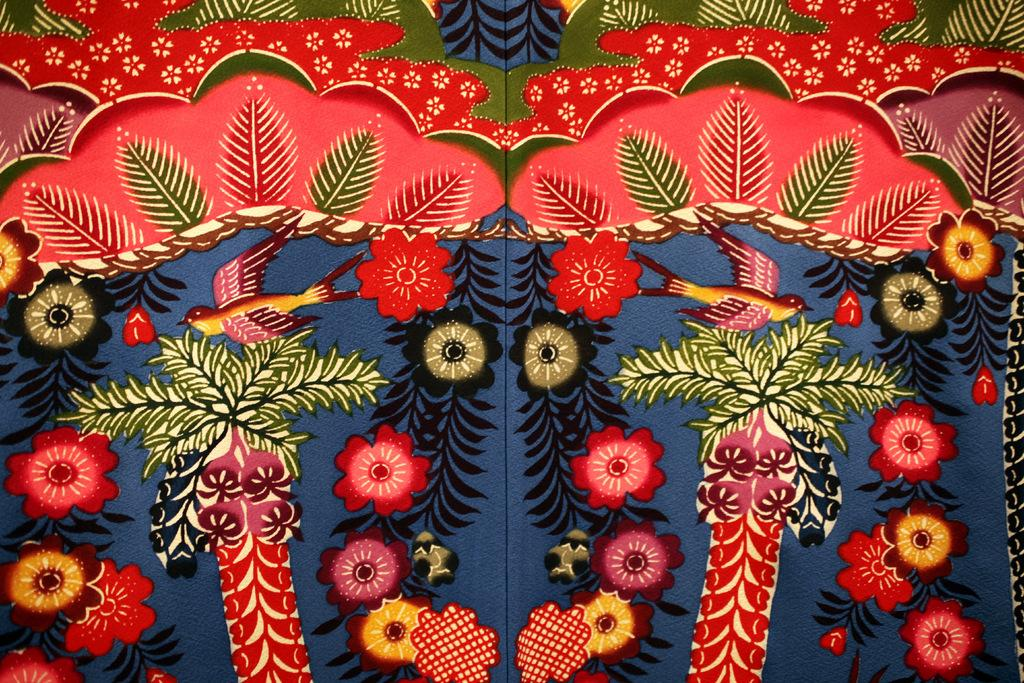What is present in the image that has designs on it? There is a blanket in the image with designs on it. What types of designs can be seen on the blanket? The blanket has flower designs, leaf designs, and tree designs. What activity is being performed on the blanket in the image? There is no activity being performed on the blanket in the image; it is simply a stationary object with designs. 